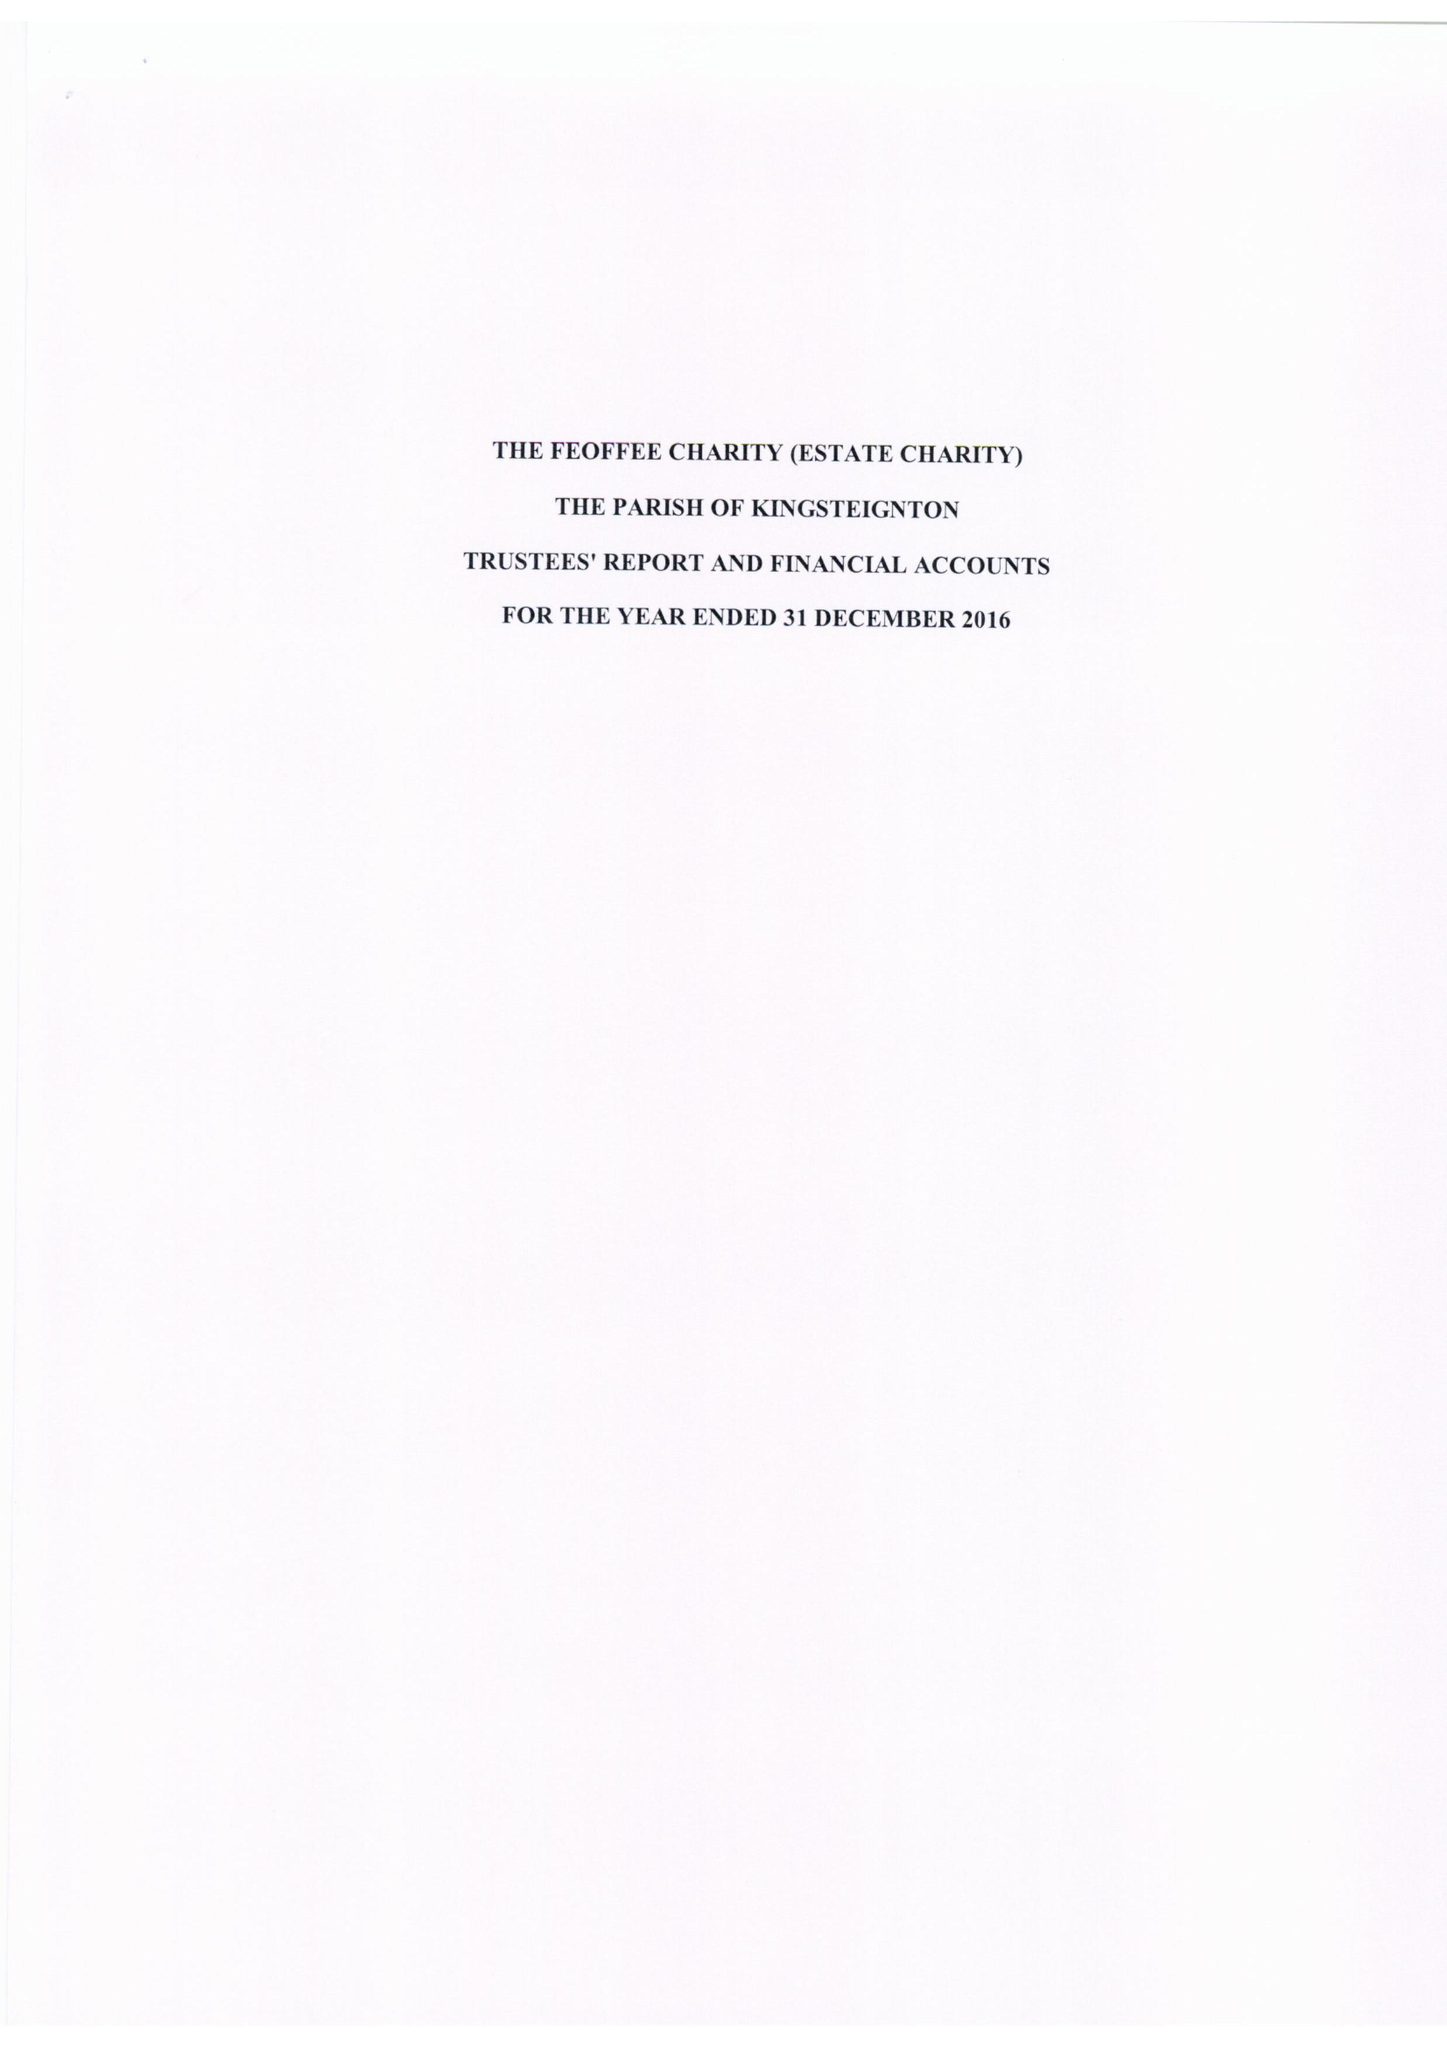What is the value for the charity_name?
Answer the question using a single word or phrase. The Feoffee Charity (Estate Charity) 